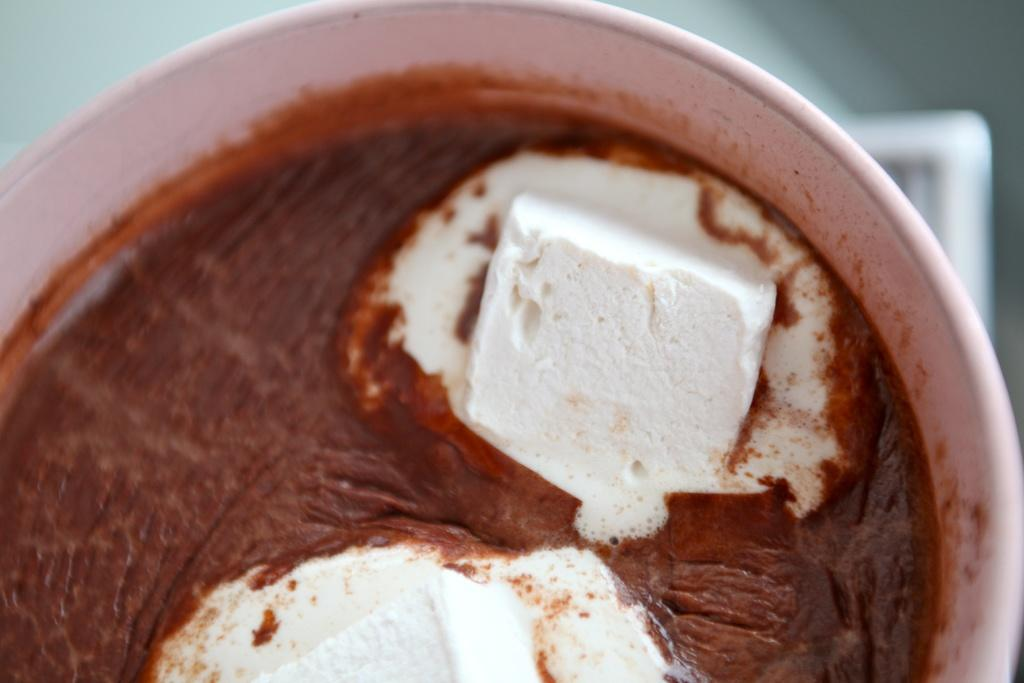What is in the cup that is visible in the image? The cup contains hot chocolate. Are there any additional items in the cup? Yes, there are marshmallows in the cup. What type of nut is used as a cushion for the seat in the image? There is no nut, seat, or cushion present in the image. 